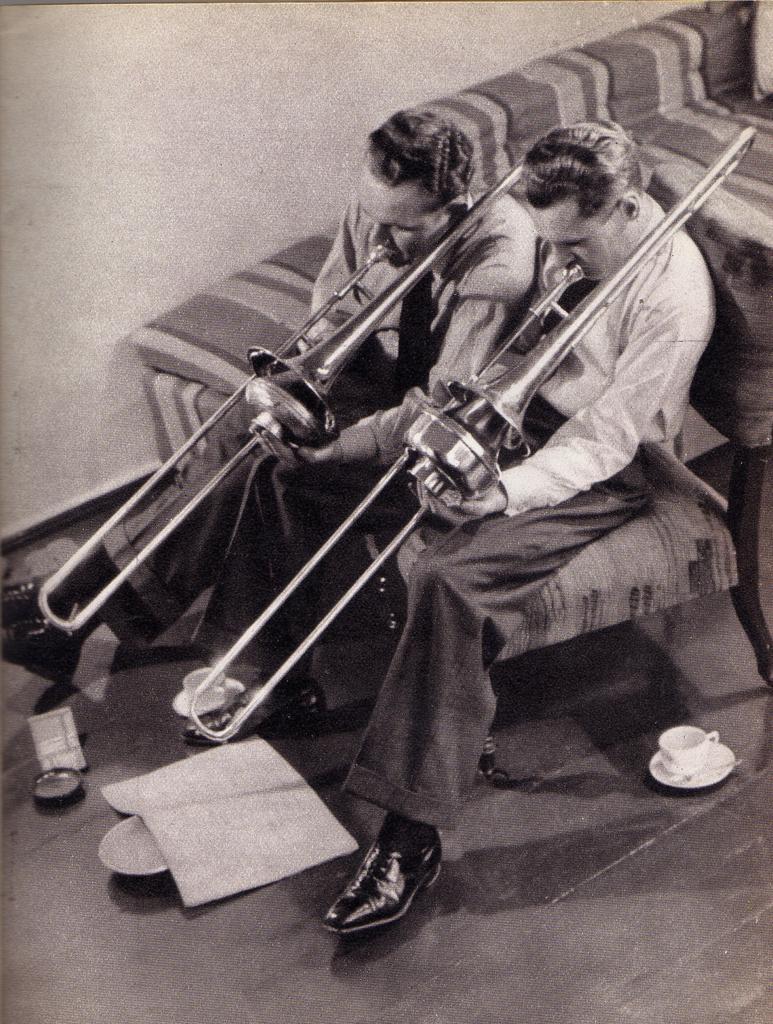In one or two sentences, can you explain what this image depicts? In this image we can see two men sitting on the sofa. They are wearing a shirt and a tie. They are playing the musical instruments. Here we can see the cups and a book on the floor. In the background, we can see another sofa. 